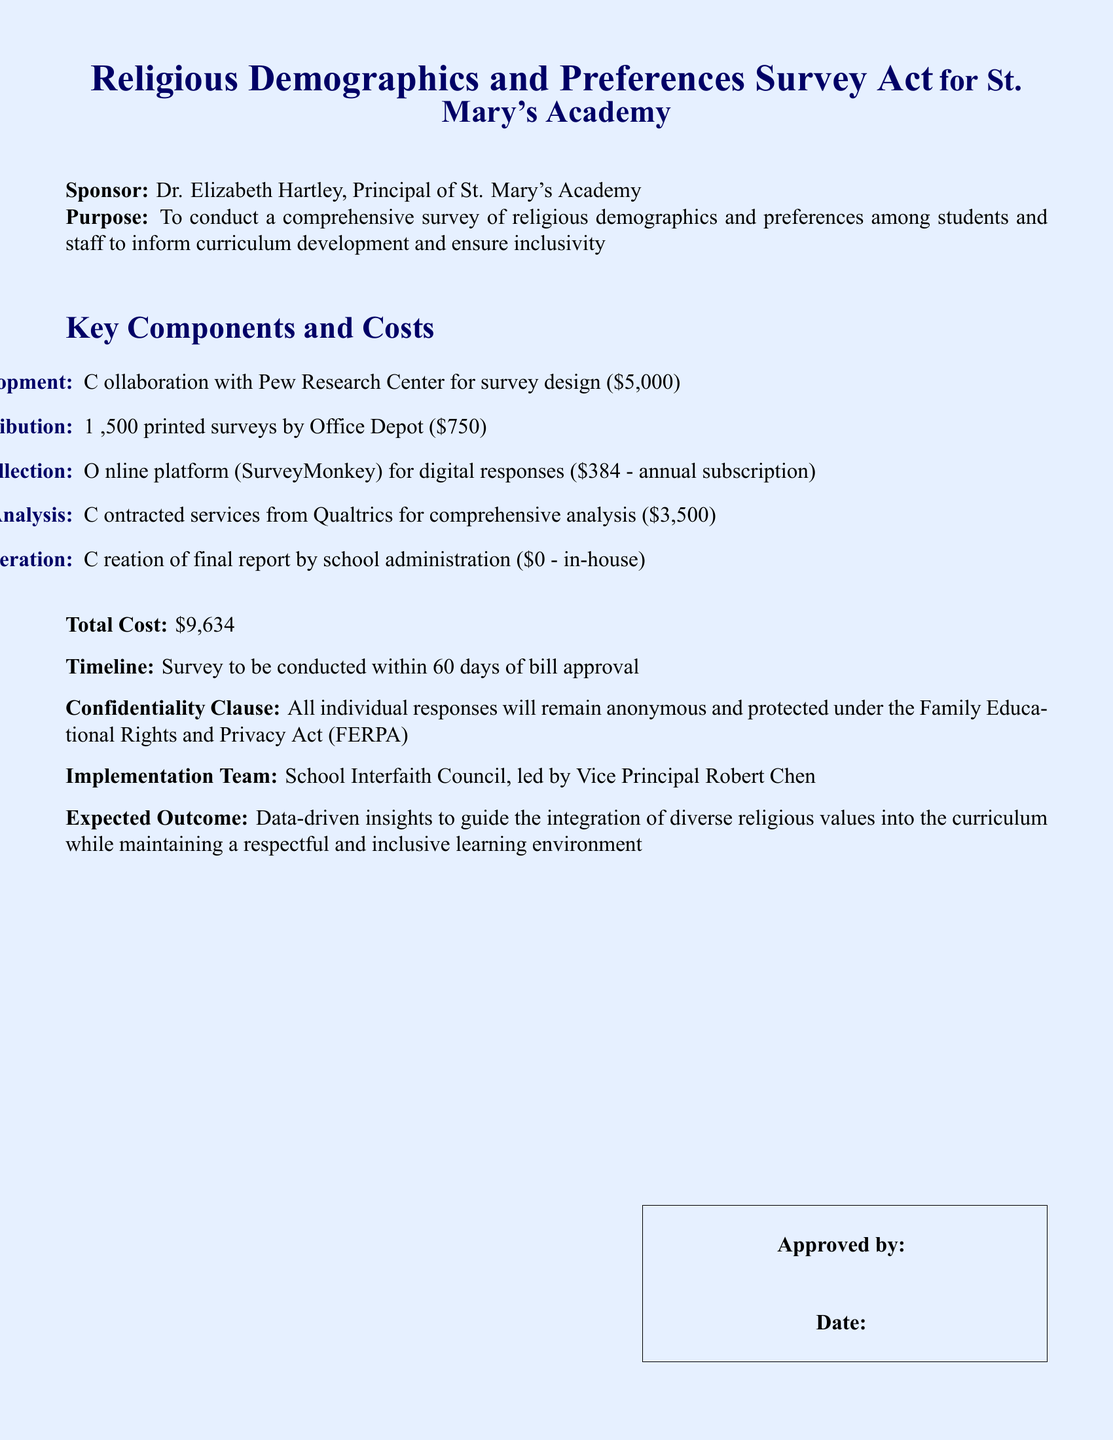What is the purpose of the bill? The purpose section explains that the bill aims to conduct a comprehensive survey of religious demographics and preferences among students and staff to inform curriculum development and ensure inclusivity.
Answer: To conduct a comprehensive survey of religious demographics and preferences among students and staff to inform curriculum development and ensure inclusivity Who is sponsoring the bill? The sponsor section names Dr. Elizabeth Hartley as the principal and sponsor of the bill.
Answer: Dr. Elizabeth Hartley What is the total cost of the survey? The total cost is stated in the document, which sums the individual costs of the survey components listed.
Answer: $9,634 How many printed surveys will be distributed? The document specifies that 1,500 printed surveys will be produced for distribution.
Answer: 1,500 What is the timeline for conducting the survey? The timeline section mentions that the survey will be conducted within 60 days of bill approval.
Answer: 60 days Who will lead the implementation team? The implementation team lead is identified as Vice Principal Robert Chen in the document.
Answer: Vice Principal Robert Chen What online platform will be used for digital responses? The document indicates that SurveyMonkey will be the online platform used for data collection.
Answer: SurveyMonkey What is the cost for data analysis? The document specifies that the contracted services for data analysis from Qualtrics will cost $3,500.
Answer: $3,500 What is included in the report generation cost? The report generation is done by the school administration and is noted as having no cost in the document.
Answer: $0 - in-house 